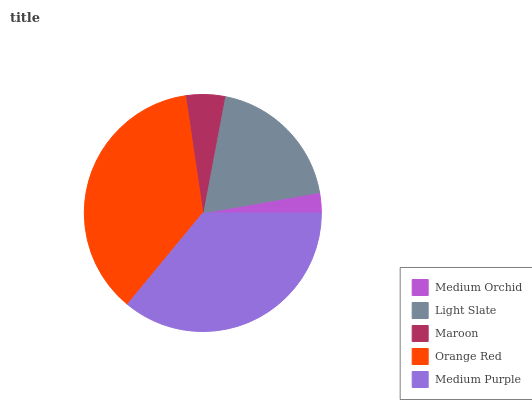Is Medium Orchid the minimum?
Answer yes or no. Yes. Is Orange Red the maximum?
Answer yes or no. Yes. Is Light Slate the minimum?
Answer yes or no. No. Is Light Slate the maximum?
Answer yes or no. No. Is Light Slate greater than Medium Orchid?
Answer yes or no. Yes. Is Medium Orchid less than Light Slate?
Answer yes or no. Yes. Is Medium Orchid greater than Light Slate?
Answer yes or no. No. Is Light Slate less than Medium Orchid?
Answer yes or no. No. Is Light Slate the high median?
Answer yes or no. Yes. Is Light Slate the low median?
Answer yes or no. Yes. Is Orange Red the high median?
Answer yes or no. No. Is Maroon the low median?
Answer yes or no. No. 